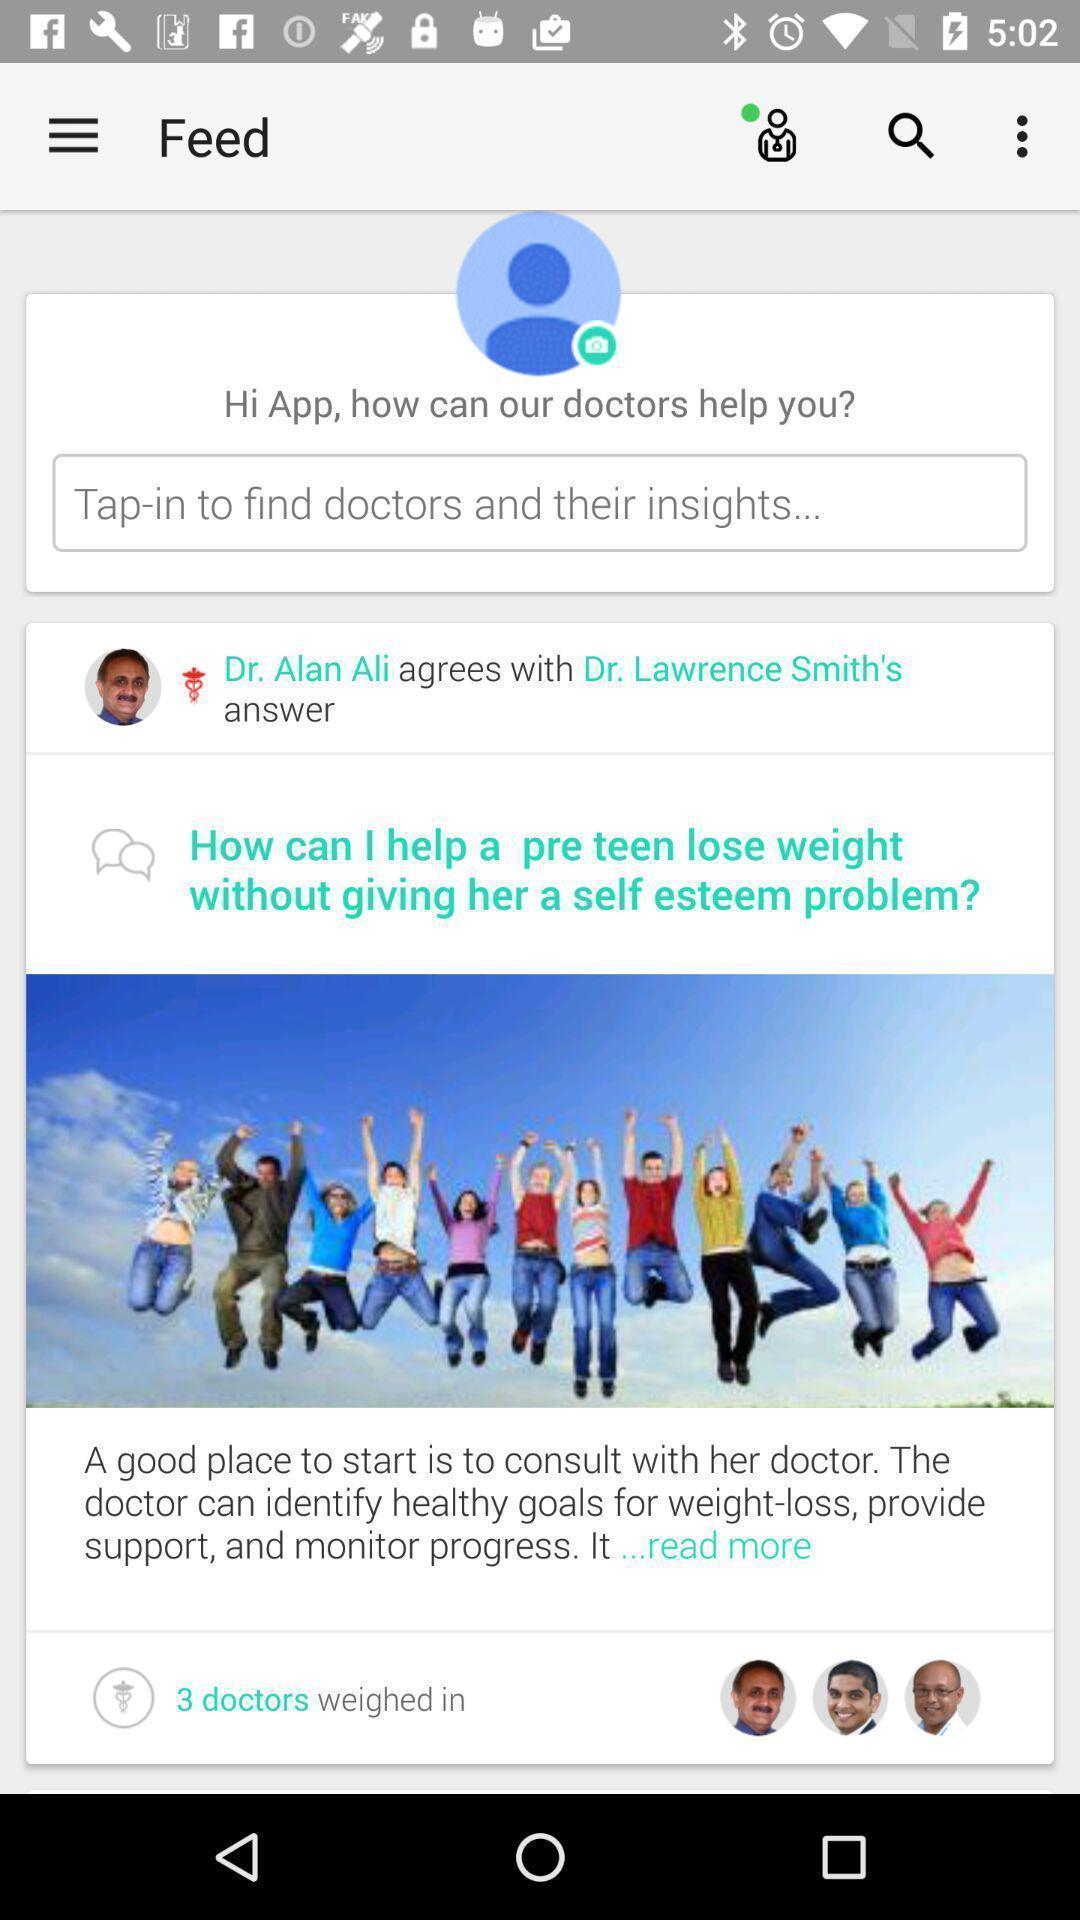Tell me what you see in this picture. Search bar to find doctors. 